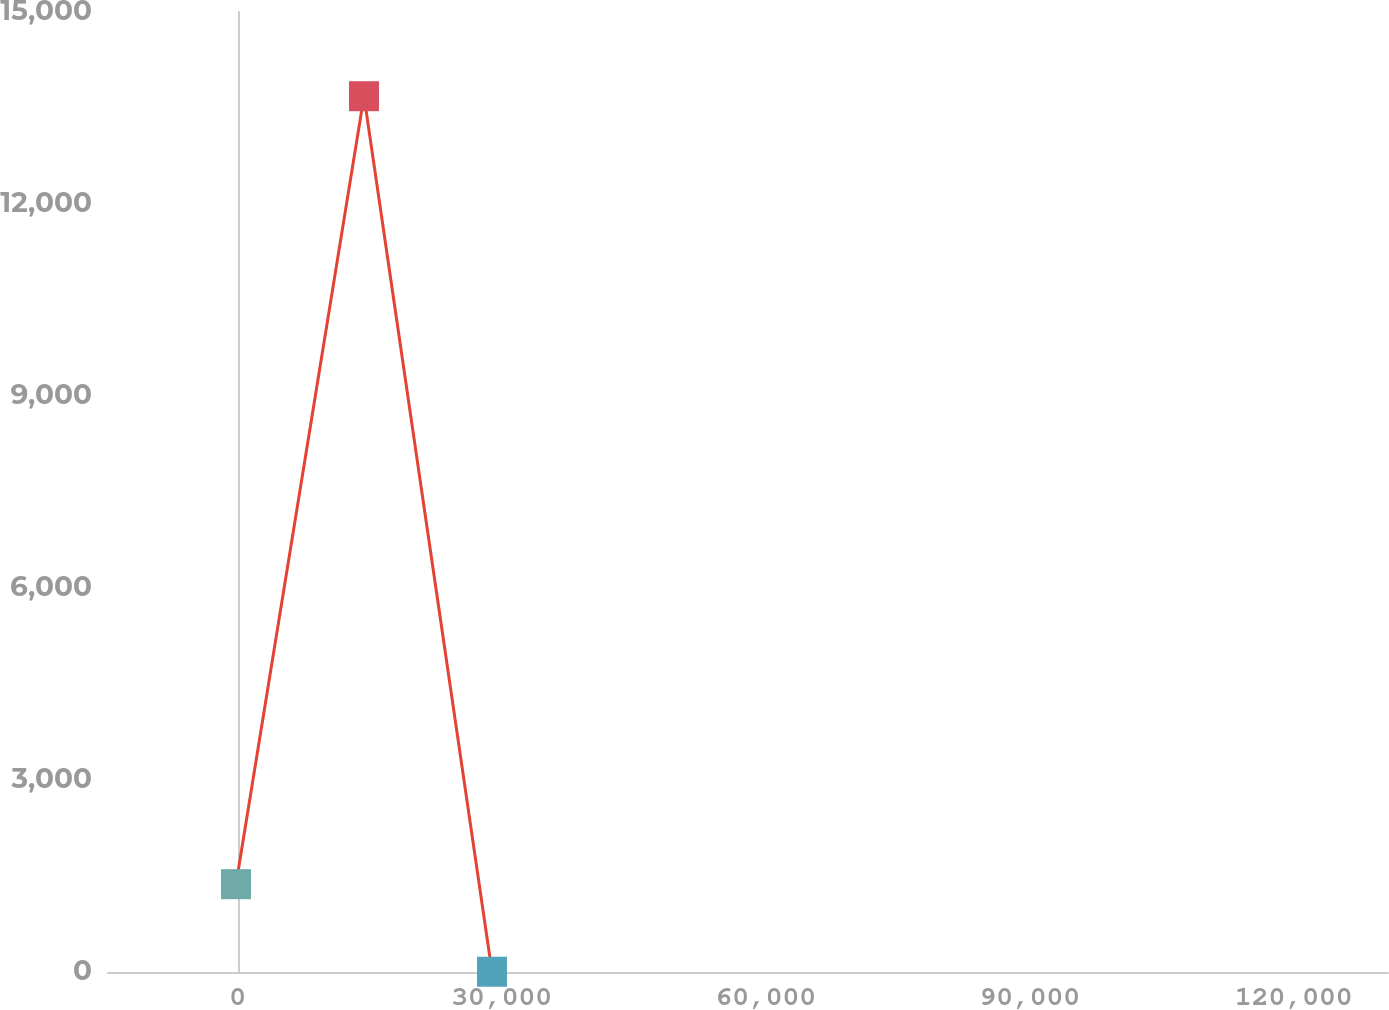<chart> <loc_0><loc_0><loc_500><loc_500><line_chart><ecel><fcel>At December 31, 2006<nl><fcel>-192.33<fcel>1372.14<nl><fcel>14351.8<fcel>13684.3<nl><fcel>28896<fcel>4.13<nl><fcel>145249<fcel>2740.15<nl></chart> 